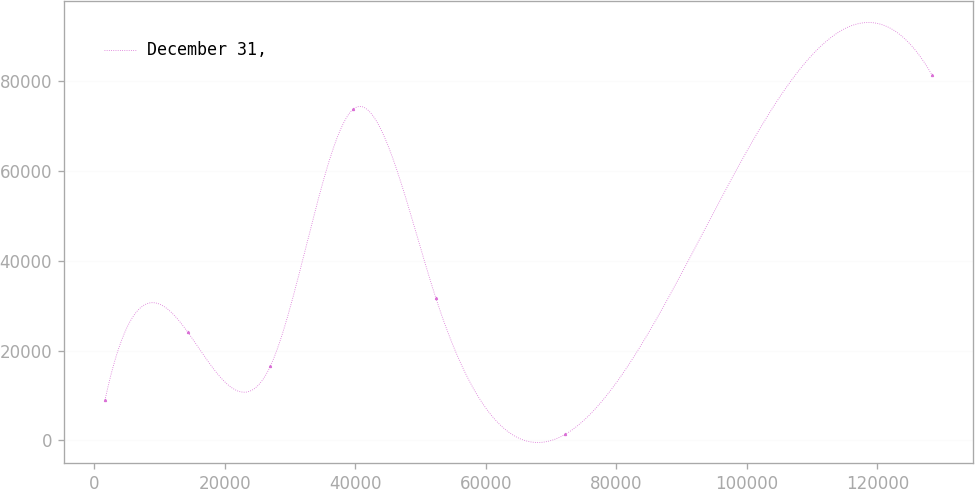Convert chart. <chart><loc_0><loc_0><loc_500><loc_500><line_chart><ecel><fcel>December 31,<nl><fcel>1656.39<fcel>8936.05<nl><fcel>14330<fcel>24126.2<nl><fcel>27003.7<fcel>16531.1<nl><fcel>39677.3<fcel>73779.8<nl><fcel>52350.9<fcel>31721.3<nl><fcel>72190.3<fcel>1340.97<nl><fcel>128393<fcel>81374.8<nl></chart> 